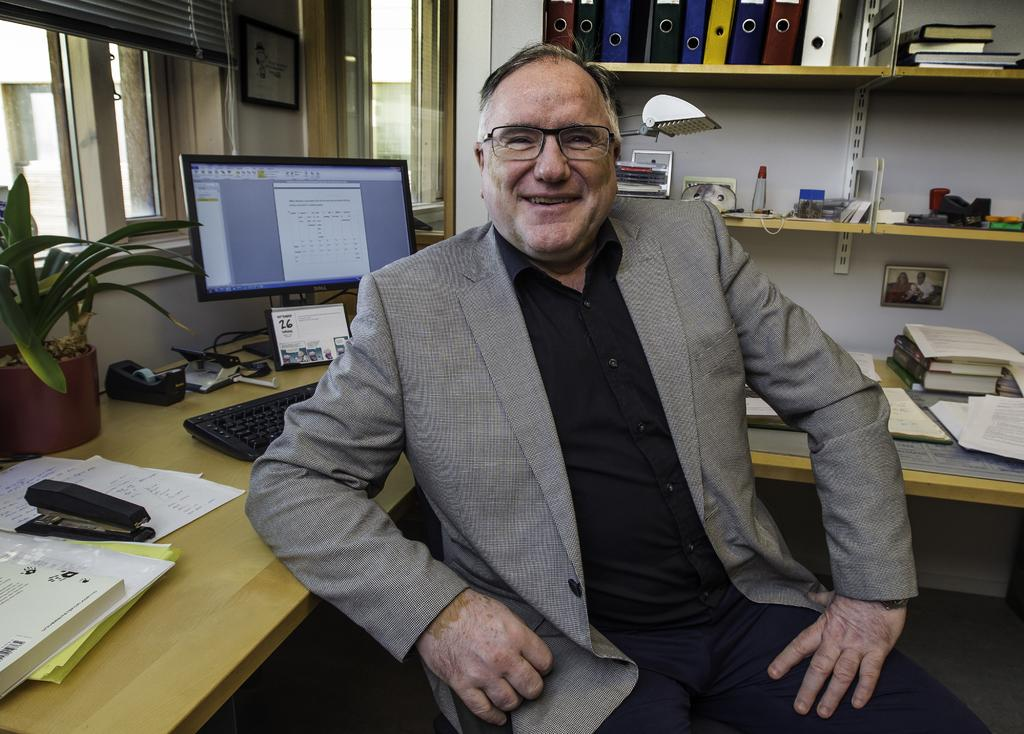Who is present in the image? There is a man in the image. What is the man doing in the image? The man is operating a monitor. Can you describe the man's facial expression? The man is smiling. What items can be seen on the table in the image? There are papers on the table. Where are the files located in the image? The files are in a shelf. Can you see a tiger in the image? No, there is no tiger present in the image. What type of picture is the man holding in the image? There is no picture visible in the image; the man is operating a monitor. 